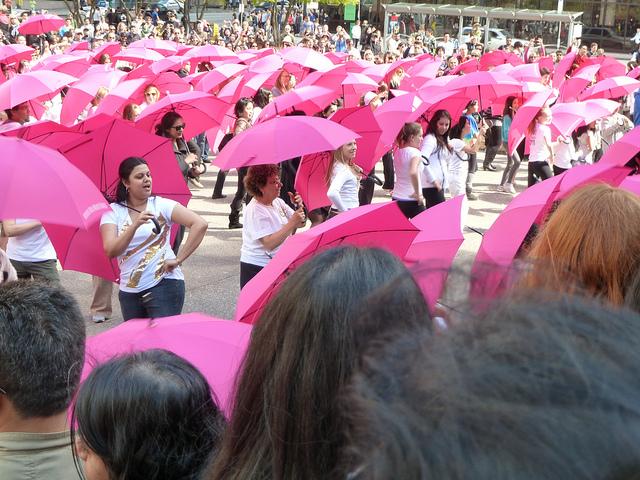Given what the umbrellas mean, one could say the walkers want to shield everyone from what?
Concise answer only. Sun. What's ironic about this photo?
Quick response, please. Pink umbrellas. Why is the umbrella pink?
Concise answer only. Breast cancer awareness. 